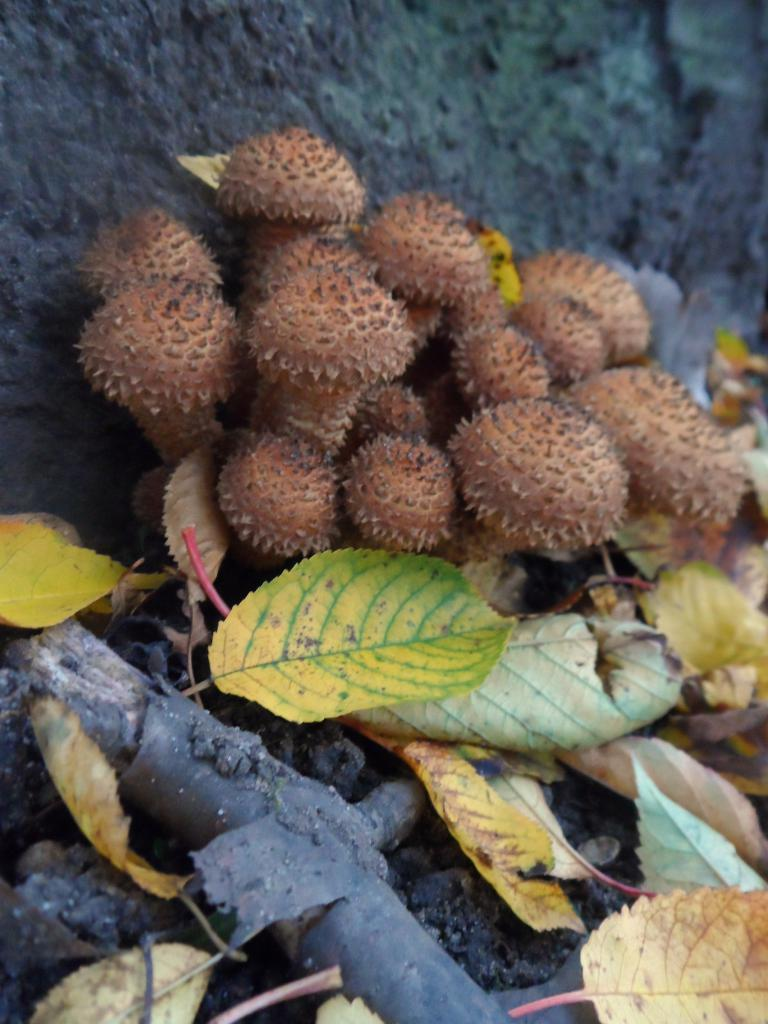What type of natural elements can be seen in the image? There are leaves, wood, and seeds in the image. Can you describe the stone visible in the background of the image? There is a stone visible in the background of the image. What time of day was the image taken? The image was taken during the day. Who is the owner of the seeds in the image? There is no indication of ownership in the image, so it cannot be determined who the owner of the seeds is. How many passengers are visible in the image? There are no passengers visible in the image, as it features natural elements and a stone. 